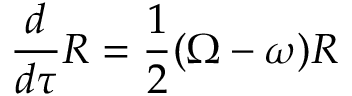Convert formula to latex. <formula><loc_0><loc_0><loc_500><loc_500>{ \frac { d } { d \tau } } R = { \frac { 1 } { 2 } } ( \Omega - \omega ) R</formula> 